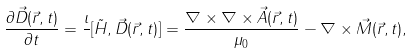<formula> <loc_0><loc_0><loc_500><loc_500>\frac { \partial \vec { D } ( \vec { r } , t ) } { \partial t } = \frac { \imath } { } [ \tilde { H } , \vec { D } ( \vec { r } , t ) ] = \frac { \nabla \times \nabla \times \vec { A } ( \vec { r } , t ) } { \mu _ { 0 } } - \nabla \times \vec { M } ( \vec { r } , t ) ,</formula> 